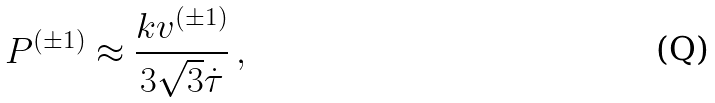Convert formula to latex. <formula><loc_0><loc_0><loc_500><loc_500>P ^ { ( \pm 1 ) } \approx \frac { k v ^ { ( \pm 1 ) } } { 3 \sqrt { 3 } \dot { \tau } } \, ,</formula> 